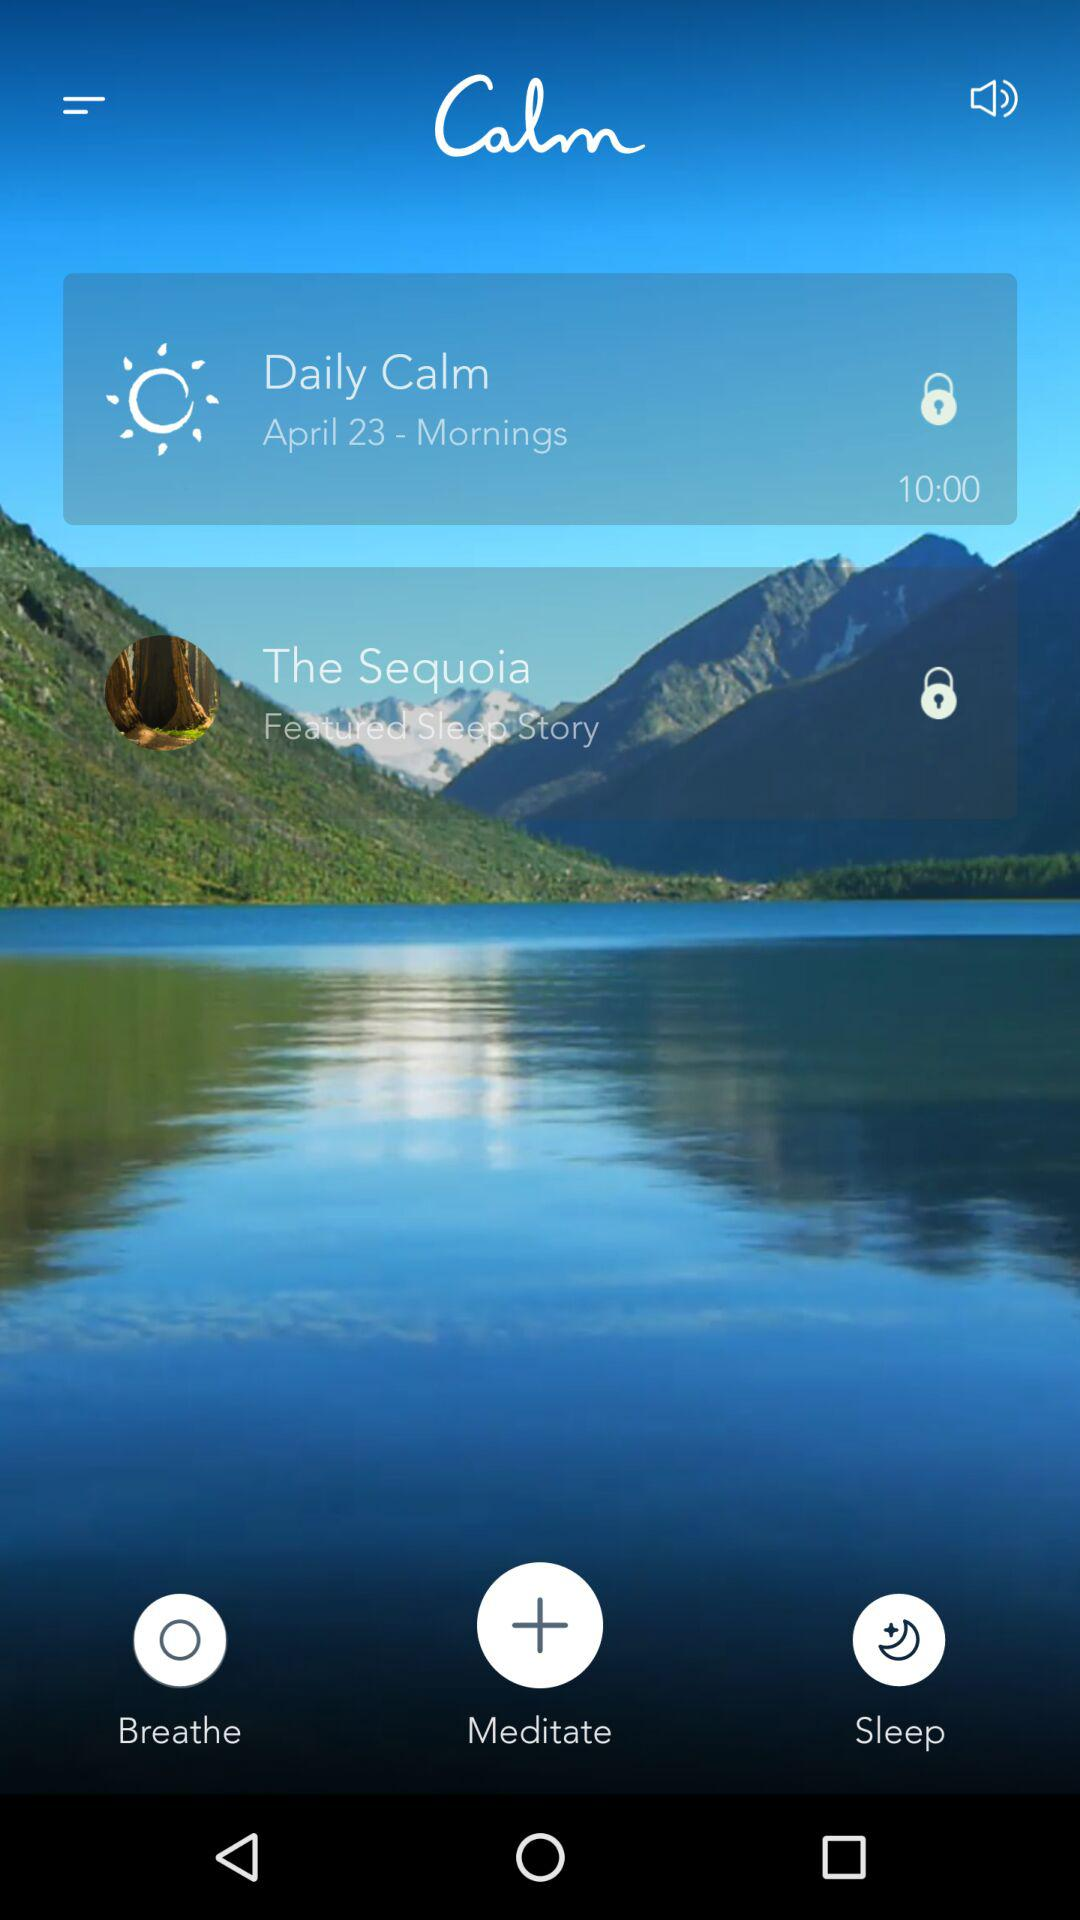What is the given date? The given date is April 23. 